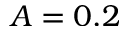Convert formula to latex. <formula><loc_0><loc_0><loc_500><loc_500>A = 0 . 2</formula> 